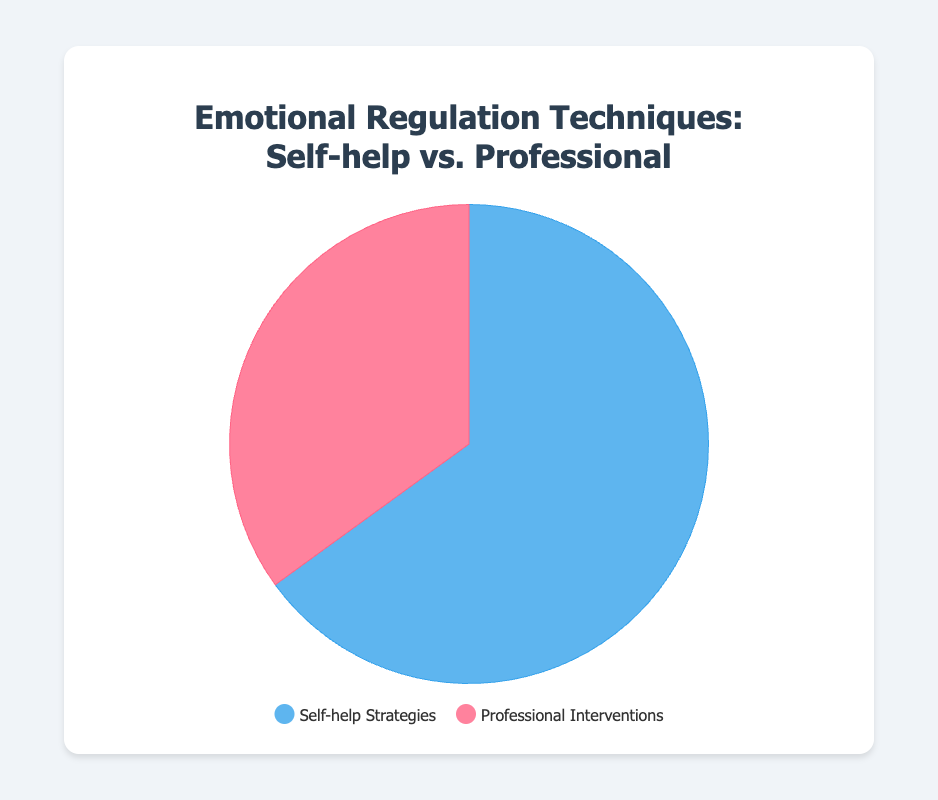what percentage of people in extreme situations use self-help strategies for emotional regulation? We see in the figure that the section labeled "Self-help Strategies" has an effectiveness of 65%. Thus, the percentage of people using self-help strategies is 65%.
Answer: 65% How does the effectiveness of self-help strategies compare to professional interventions? By looking at the pie chart, we see that self-help strategies account for 65% while professional interventions account for 35%. Hence, self-help strategies are more effective.
Answer: more effective Which type of emotional regulation technique is more effective? According to the pie chart, self-help strategies account for 65%, which is greater than the 35% for professional interventions. Therefore, self-help strategies are more effective.
Answer: self-help strategies What is the combined effectiveness of both techniques? Sum the effectiveness of self-help strategies (65%) and professional interventions (35%). This gives 65 + 35 = 100%.
Answer: 100% What is the difference in effectiveness between self-help strategies and professional interventions? The pie chart shows that self-help strategies are 65% and professional interventions are 35%. The difference is 65 - 35 = 30%.
Answer: 30% What visual attribute represents the self-help strategies segment? The pie chart uses a specific color to represent each segment. The self-help strategies segment is shown in blue.
Answer: blue Which technique is represented by the larger segment on the pie chart? Observing the pie chart, the larger segment, which is in blue, represents self-help strategies.
Answer: self-help strategies What color is used to represent professional interventions? The pie chart uses different colors for each segment. The segment for professional interventions is represented in red.
Answer: red 